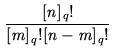Convert formula to latex. <formula><loc_0><loc_0><loc_500><loc_500>\frac { [ n ] _ { q } ! } { [ m ] _ { q } ! [ n - m ] _ { q } ! }</formula> 